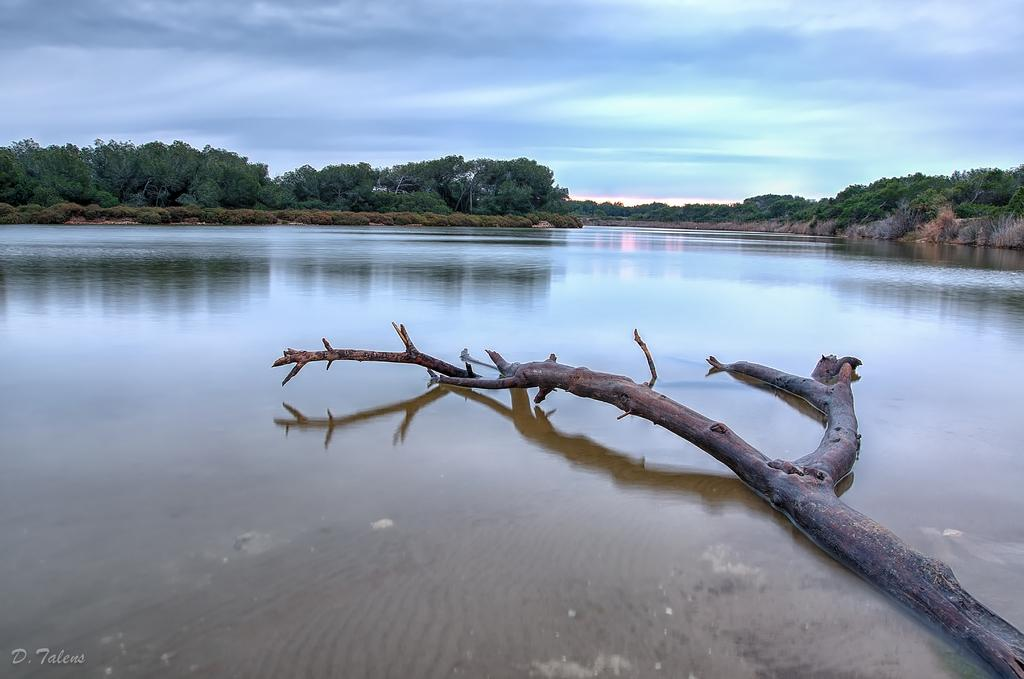What type of vegetation can be seen in the image? There are trees in the image. What natural element is present alongside the trees? There is water in the image. Can you describe the condition of the fallen tree in the image? The fallen tree is in the water. How would you describe the sky in the image? The sky is blue and cloudy. Where is the text located in the image? The text is at the bottom left corner of the image. What type of request can be seen being made to the moon in the image? There is no moon present in the image, and therefore no request can be made to it. How many yams are visible in the image? There are no yams present in the image. 